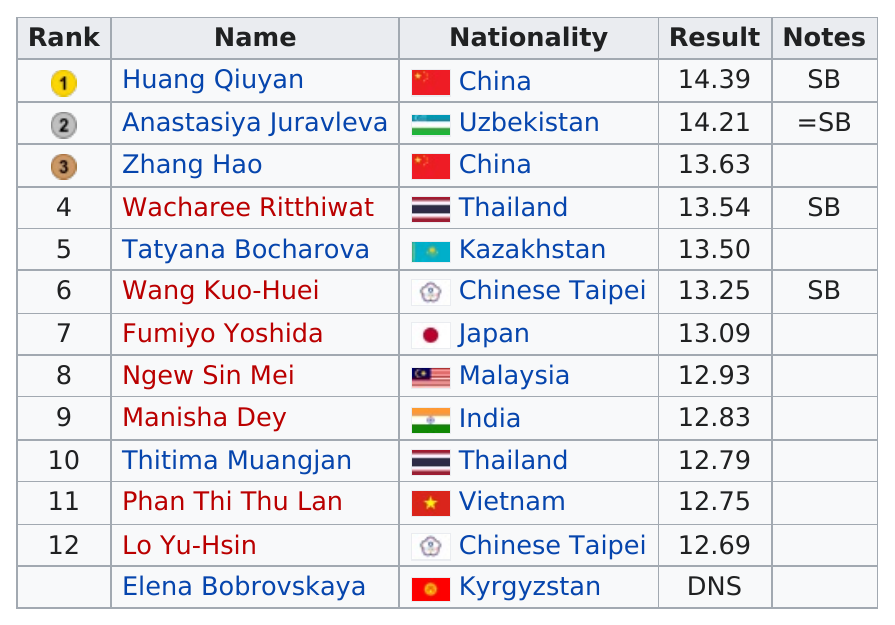Identify some key points in this picture. China came in first among all countries. Manisha Dey's jump was 12.83 meters. Out of all the competitors, six of them had less than 13.00 points. The number of contestants from Thailand was two. Four different nationalities are represented among the top five athletes. 